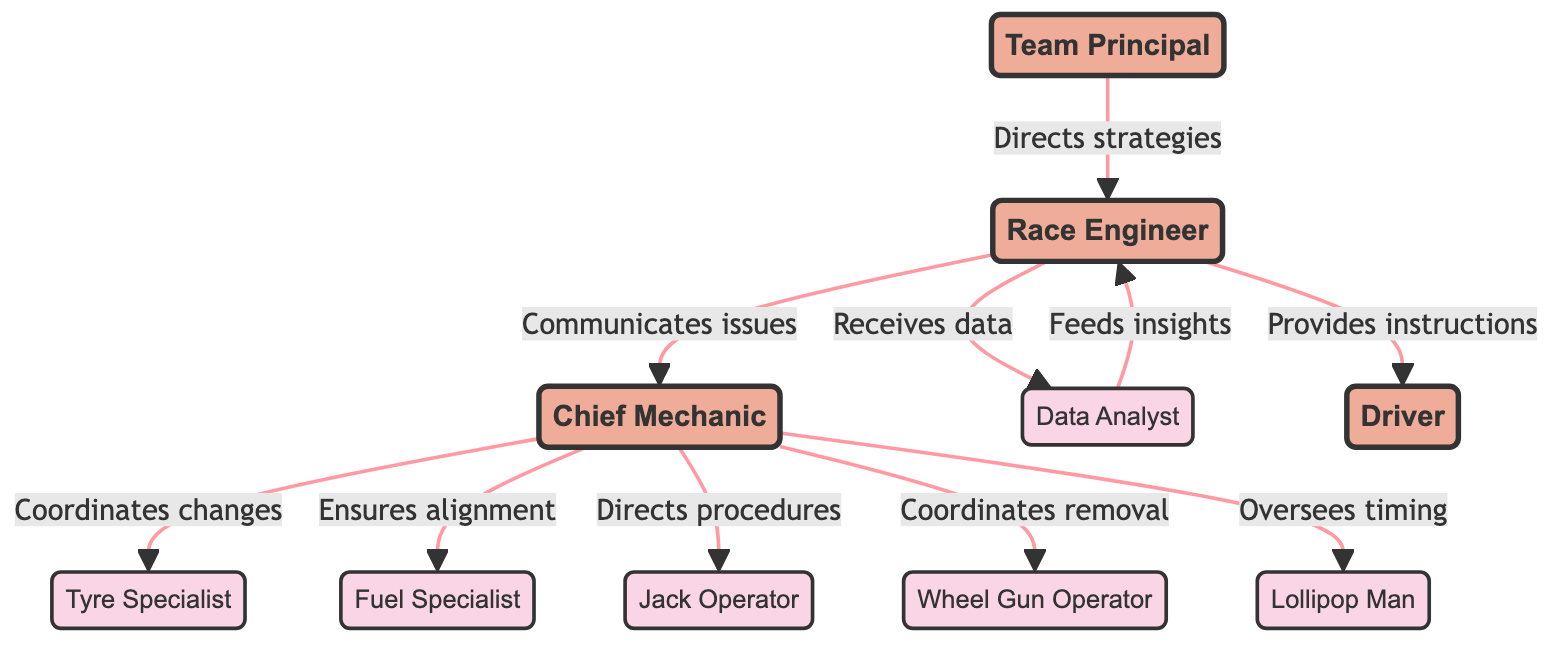What is the main role that oversees the entire team operations? The "Team Principal" node explicitly describes the role of overseeing the entire team operations. This is a straightforward identification of a role presented in the diagram.
Answer: Team Principal How many roles are there in the pit crew network diagram? Counting the entries in the "nodes" section, there are a total of 9 roles depicted in the diagram.
Answer: 9 Who does the Chief Mechanic coordinate with for tyre changes? The "Tyre Specialist" is directly linked to the "Chief Mechanic" through the relationship of coordinating tyre changes in the diagram.
Answer: Tyre Specialist What relationship does the Race Engineer have with the Driver? The connection between the "RaceEngineer" and "Driver" is that the Race Engineer provides race and pit stop instructions, which is clearly stated in the diagram.
Answer: Provides instructions Which role is primarily responsible for managing fuel strategies? The "Fuel Specialist" is designated to oversee and manage fuel strategies in the context of the diagram.
Answer: Fuel Specialist How does the Data Analyst contribute to the Race Engineer? The "Data Analyst" provides data insights to the "Race Engineer," as demonstrated by the direction and relationship link between the two roles.
Answer: Feeds insights Identify the two roles that the Chief Mechanic coordinates with for pit stop execution. The Chief Mechanic directly coordinates with both the "Wheel Gun Operator" for tyre removal and the "Jack Operator" for directing procedures, as per the connections in the diagram.
Answer: Wheel Gun Operator and Jack Operator Which role directly sends performance data to the Race Engineer? The "Data Analyst" is linked to the "Race Engineer" with a direct relationship of the Race Engineer receiving performance data.
Answer: Data Analyst What is the relationship between the Team Principal and Race Engineer? The direct relationship is that the "Team Principal" directs strategies and decisions towards the "Race Engineer," establishing a clear hierarchical communication flow.
Answer: Directs strategies 